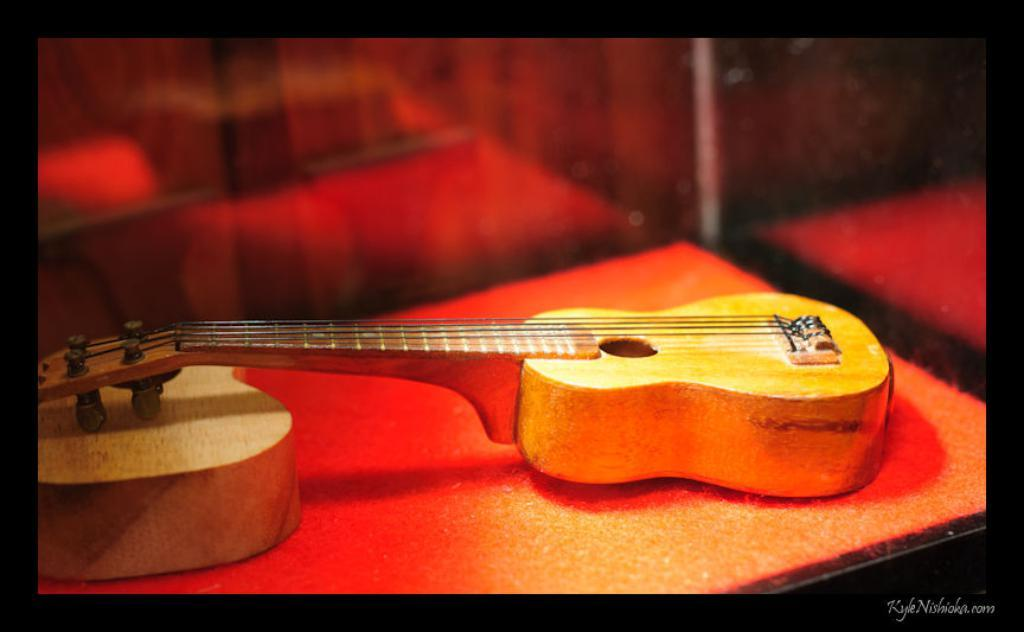What musical instrument is present in the image? There is a guitar in the image. Where is the guitar placed? The guitar is on a table. What is the color of the table? The table is orange in color. What can be found in the right bottom of the image? There is text in the right bottom of the image. Where was the image taken? The image was taken inside a room. What type of crime is being committed in the image? There is no indication of a crime being committed in the image; it features a guitar on an orange table with text in the right bottom corner. 